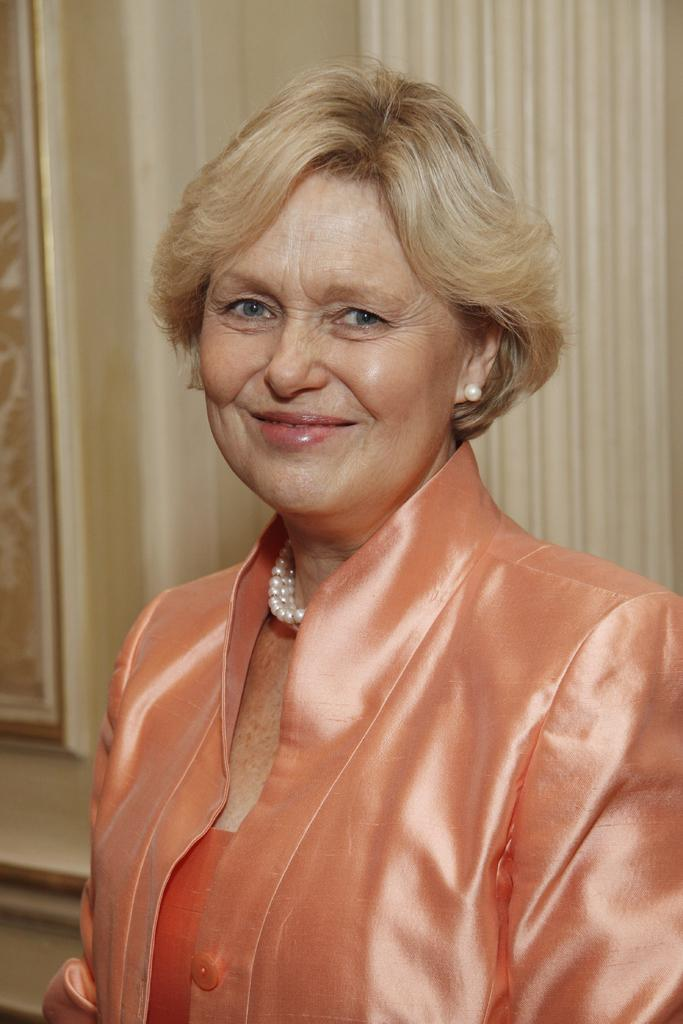Who is present in the image? There is a woman in the image. What is the woman wearing? The woman is wearing an orange dress. What can be seen in the background of the image? There is a photo frame in the background of the image. What type of farm animals can be seen in the image? There are no farm animals present in the image. What kind of camping equipment is visible in the image? There is no camping equipment present in the image. 